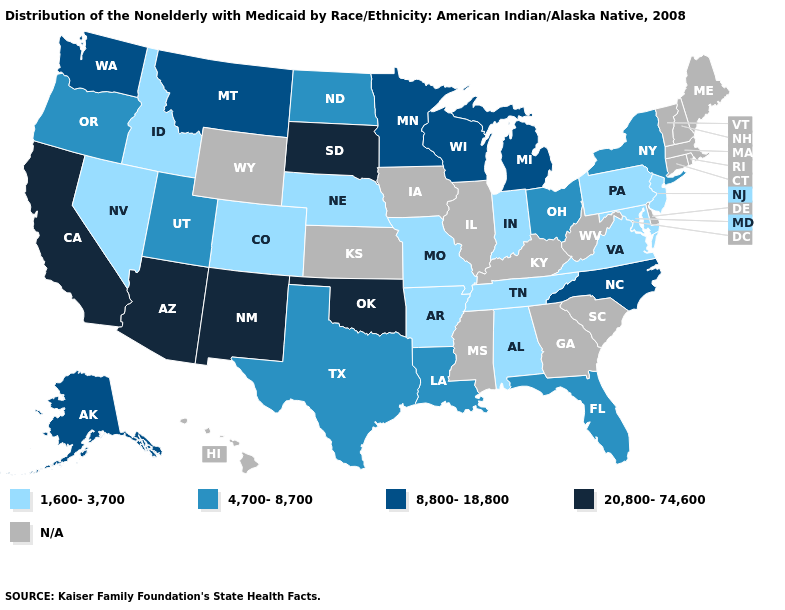Among the states that border Georgia , does Alabama have the lowest value?
Write a very short answer. Yes. Which states have the highest value in the USA?
Answer briefly. Arizona, California, New Mexico, Oklahoma, South Dakota. Name the states that have a value in the range 8,800-18,800?
Write a very short answer. Alaska, Michigan, Minnesota, Montana, North Carolina, Washington, Wisconsin. Name the states that have a value in the range 4,700-8,700?
Short answer required. Florida, Louisiana, New York, North Dakota, Ohio, Oregon, Texas, Utah. Does Alabama have the lowest value in the South?
Quick response, please. Yes. How many symbols are there in the legend?
Short answer required. 5. How many symbols are there in the legend?
Short answer required. 5. Does the first symbol in the legend represent the smallest category?
Give a very brief answer. Yes. What is the value of Kansas?
Keep it brief. N/A. How many symbols are there in the legend?
Short answer required. 5. Which states have the highest value in the USA?
Short answer required. Arizona, California, New Mexico, Oklahoma, South Dakota. Name the states that have a value in the range 8,800-18,800?
Quick response, please. Alaska, Michigan, Minnesota, Montana, North Carolina, Washington, Wisconsin. Does the map have missing data?
Quick response, please. Yes. What is the highest value in the USA?
Quick response, please. 20,800-74,600. What is the highest value in the USA?
Quick response, please. 20,800-74,600. 